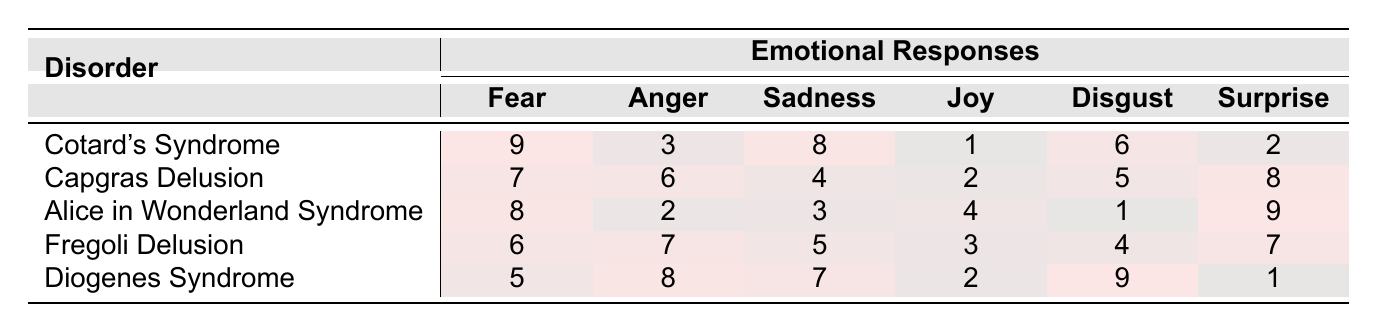What is the highest emotional response recorded for Cotard's Syndrome? The table shows that Cotard's Syndrome has the highest emotional response value of 9, which corresponds to the emotional response of fear.
Answer: 9 Which disorder has the lowest recorded response for joy? In the table, joy has the lowest value of 1 for Cotard's Syndrome, indicating it has the least emotional response for this disorder.
Answer: Cotard's Syndrome What is the average level of anger across all disorders? To find the average, sum the anger values (3 + 6 + 2 + 7 + 8 = 26) and divide by the number of disorders (5): 26 / 5 = 5.2.
Answer: 5.2 Is the sadness response higher for Diogenes Syndrome compared to Alice in Wonderland Syndrome? Diogenes Syndrome has a sadness response of 7, while Alice in Wonderland Syndrome has a sadness response of 3, making Diogenes Syndrome higher by 4.
Answer: Yes What is the emotional response pattern for Capgras Delusion in order from highest to lowest? For Capgras Delusion, the responses are as follows: Surprise (8), Anger (6), Disgust (5), Fear (7), Sadness (4), and Joy (2). When sorted, the order is Surprise (8), Anger (6), Disgust (5), Fear (7), Sadness (4), and Joy (2). Thus, the order is Surprise, Anger, Fear, Disgust, Sadness, Joy.
Answer: Surprise, Anger, Fear, Disgust, Sadness, Joy Which disorder shows the highest response for disgust and how does it compare to joy? Diogenes Syndrome has the highest disgust response at 9, while joy has a response of 2 for the same disorder, showing that disgust is 7 points higher than joy.
Answer: Diogenes Syndrome; 7 points higher What is the total emotional response for all emotions in Fregoli Delusion? The values for Fregoli Delusion are: Fear (6), Anger (7), Sadness (5), Joy (3), Disgust (4), Surprise (7). Adding these gives a total of 6 + 7 + 5 + 3 + 4 + 7 = 32.
Answer: 32 Which disorder exhibits the greatest discrepancy between fear and joy? Comparing fear and joy responses for each disorder, the discrepancies are: Cotard's (8), Capgras (5), Alice in Wonderland (4), Fregoli (3), and Diogenes (3). Cotard’s Syndrome has the highest discrepancy of 8.
Answer: Cotard's Syndrome Does Alice in Wonderland Syndrome show a higher response for surprise than for sadness? Alice in Wonderland Syndrome has a surprise response of 9 and a sadness response of 3, indicating that surprise is indeed higher than sadness.
Answer: Yes What is the sum of emotional responses for disgust across all disorders? The disgust responses for each disorder are: Cotard's (6), Capgras (5), Alice in Wonderland (1), Fregoli (4), and Diogenes (9). Adding these gives 6 + 5 + 1 + 4 + 9 = 25.
Answer: 25 How does the average fear response compare to the average sadness response across all disorders? The average fear response is (9 + 7 + 8 + 6 + 5) / 5 = 7, while the average sadness response is (8 + 4 + 3 + 5 + 7) / 5 = 5.4; hence, fear is higher at an average of 7.
Answer: Fear is higher 